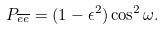<formula> <loc_0><loc_0><loc_500><loc_500>P _ { \overline { e } \overline { e } } = ( 1 - \epsilon ^ { 2 } ) \cos ^ { 2 } \omega . \,</formula> 